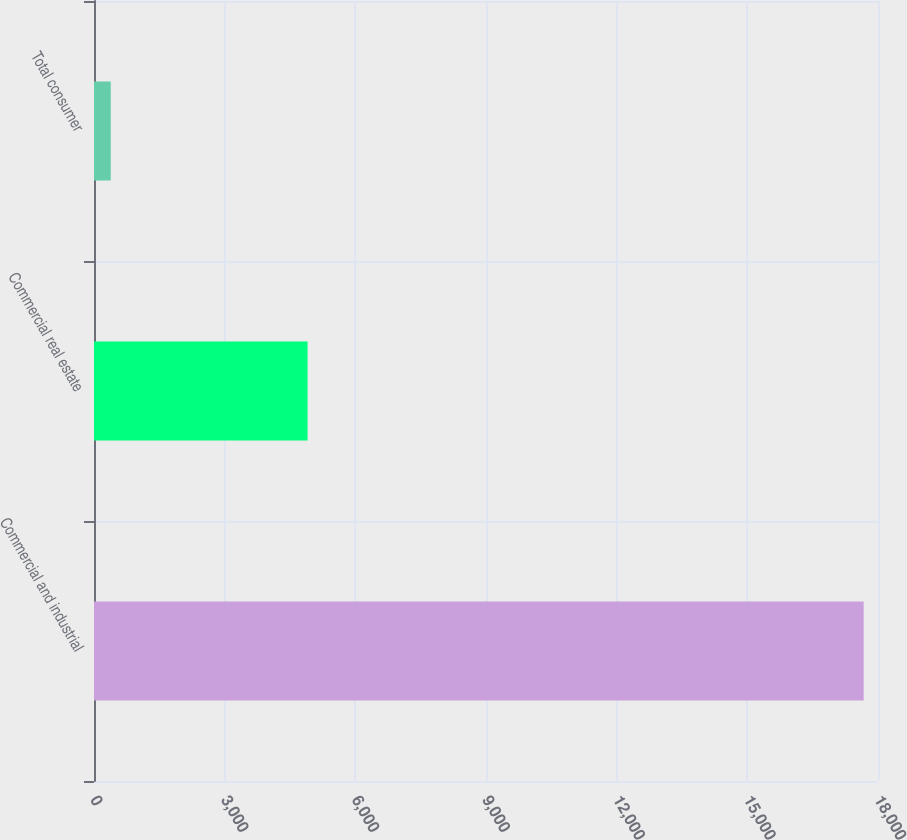<chart> <loc_0><loc_0><loc_500><loc_500><bar_chart><fcel>Commercial and industrial<fcel>Commercial real estate<fcel>Total consumer<nl><fcel>17671<fcel>4904<fcel>385<nl></chart> 